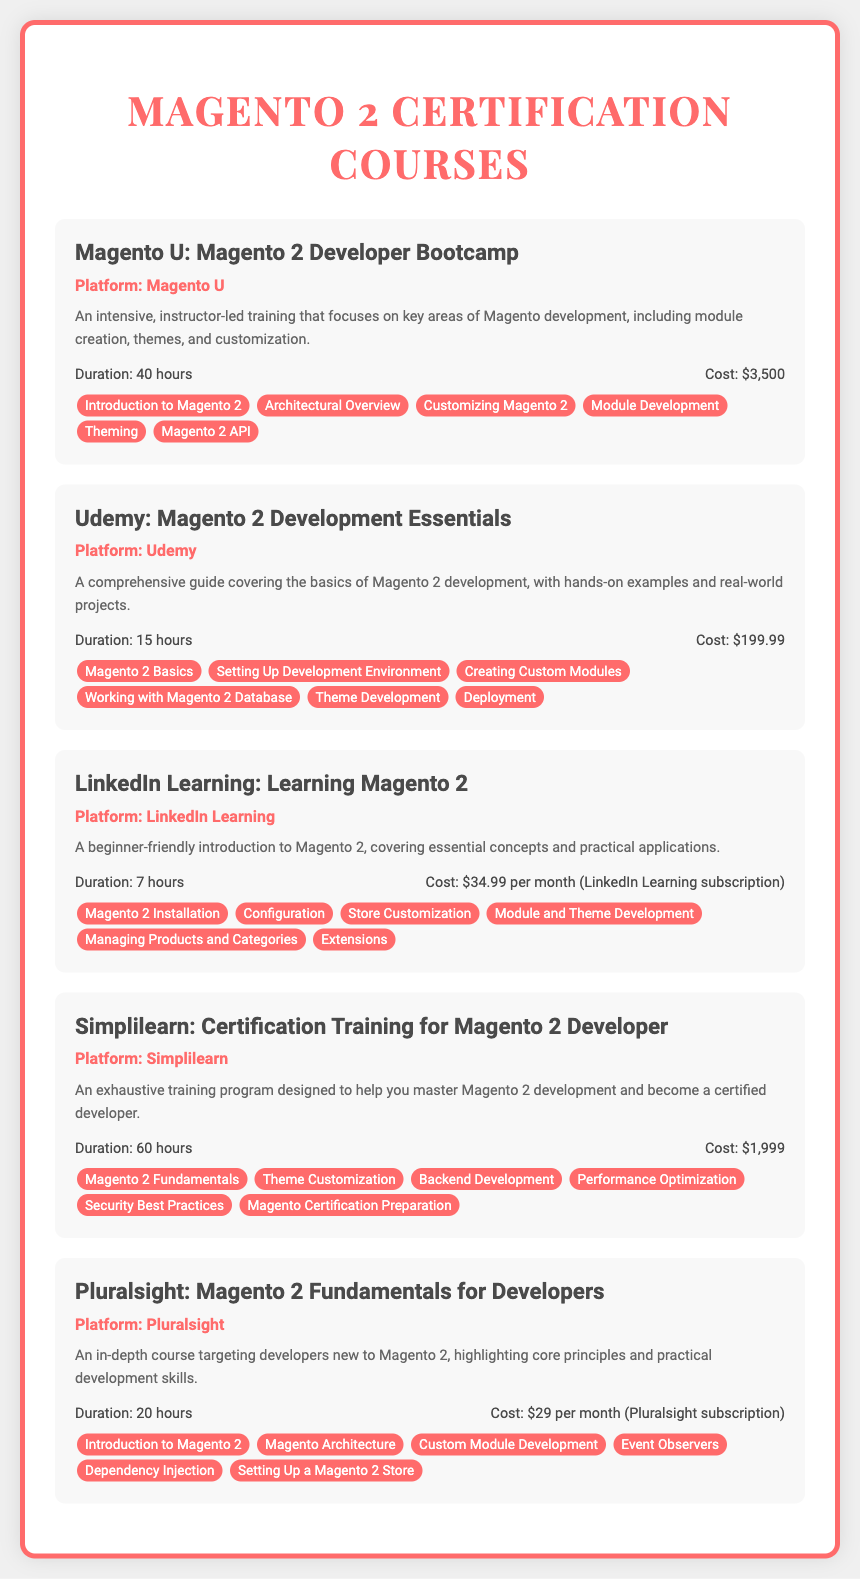What is the title of the first course listed? The title of the first course is provided at the beginning of its section in the document.
Answer: Magento U: Magento 2 Developer Bootcamp What is the cost of the Udemy course? The cost of the Udemy course is found in the details section of that course.
Answer: $199.99 How long is the Simplilearn course? The duration of the Simplilearn course is stated in the details section of the course.
Answer: 60 hours Which platform offers a course for $29 per month? The platform offering a course for $29 is mentioned in the details section of the respective course.
Answer: Pluralsight What key topic is included in the LinkedIn Learning course? One of the key topics is listed in the key topics section of the LinkedIn Learning course.
Answer: Configuration Which course has the longest duration? The longest duration can be determined by comparing the durations listed in the details section of each course.
Answer: Magento U: Magento 2 Developer Bootcamp What certification can you prepare for in the Simplilearn course? The certification that can be prepared for is indicated in the key topics section of the Simplilearn course.
Answer: Magento Certification Preparation Which course focuses on practical applications for beginners? The course described as focusing on practical applications for beginners in its description is noted in the document.
Answer: Learning Magento 2 What is the primary focus of the Pluralsight course? The primary focus of the Pluralsight course is stated in its description section.
Answer: Core principles and practical development skills 